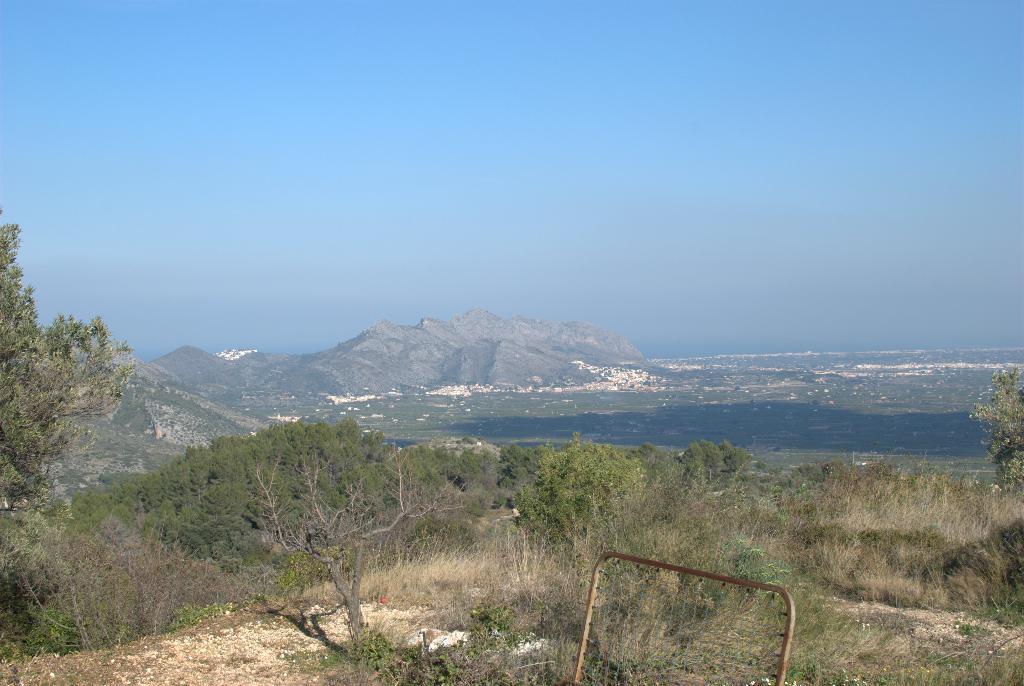In one or two sentences, can you explain what this image depicts? In this picture I can see many trees, plants and grass. In the background I can see the ocean and mountains. At the top there is a sky. At the bottom there is a steel pipe. 